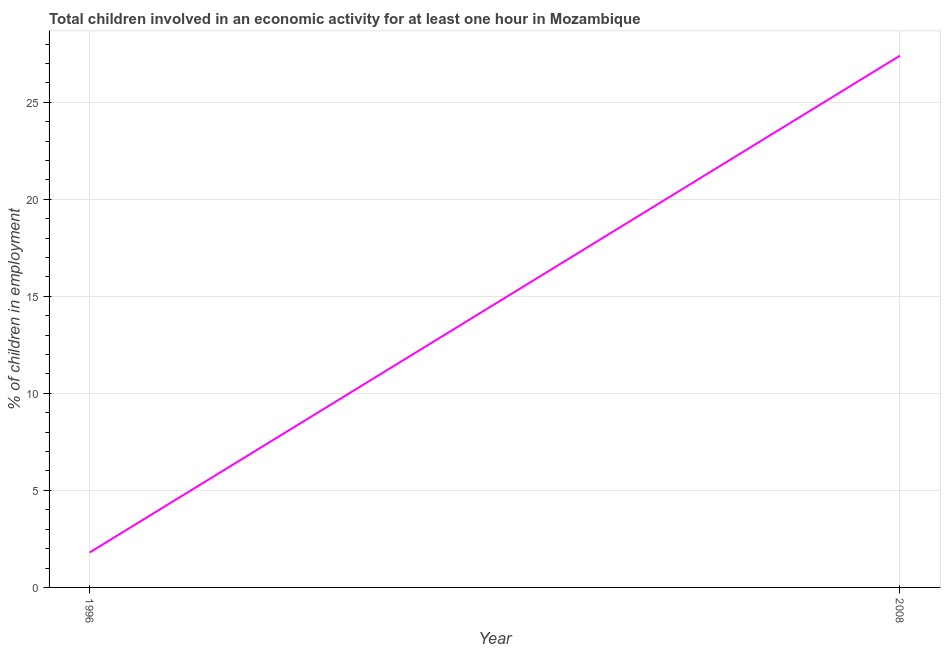What is the percentage of children in employment in 2008?
Offer a very short reply. 27.4. Across all years, what is the maximum percentage of children in employment?
Provide a succinct answer. 27.4. Across all years, what is the minimum percentage of children in employment?
Keep it short and to the point. 1.8. In which year was the percentage of children in employment minimum?
Keep it short and to the point. 1996. What is the sum of the percentage of children in employment?
Keep it short and to the point. 29.2. What is the difference between the percentage of children in employment in 1996 and 2008?
Provide a short and direct response. -25.6. What is the average percentage of children in employment per year?
Your answer should be compact. 14.6. What is the median percentage of children in employment?
Your answer should be very brief. 14.6. Do a majority of the years between 1996 and 2008 (inclusive) have percentage of children in employment greater than 2 %?
Your response must be concise. No. What is the ratio of the percentage of children in employment in 1996 to that in 2008?
Offer a terse response. 0.07. Is the percentage of children in employment in 1996 less than that in 2008?
Give a very brief answer. Yes. In how many years, is the percentage of children in employment greater than the average percentage of children in employment taken over all years?
Ensure brevity in your answer.  1. How many lines are there?
Your answer should be very brief. 1. How many years are there in the graph?
Provide a succinct answer. 2. Does the graph contain any zero values?
Your answer should be compact. No. Does the graph contain grids?
Make the answer very short. Yes. What is the title of the graph?
Give a very brief answer. Total children involved in an economic activity for at least one hour in Mozambique. What is the label or title of the X-axis?
Provide a succinct answer. Year. What is the label or title of the Y-axis?
Provide a short and direct response. % of children in employment. What is the % of children in employment of 1996?
Make the answer very short. 1.8. What is the % of children in employment of 2008?
Your answer should be very brief. 27.4. What is the difference between the % of children in employment in 1996 and 2008?
Your response must be concise. -25.6. What is the ratio of the % of children in employment in 1996 to that in 2008?
Give a very brief answer. 0.07. 